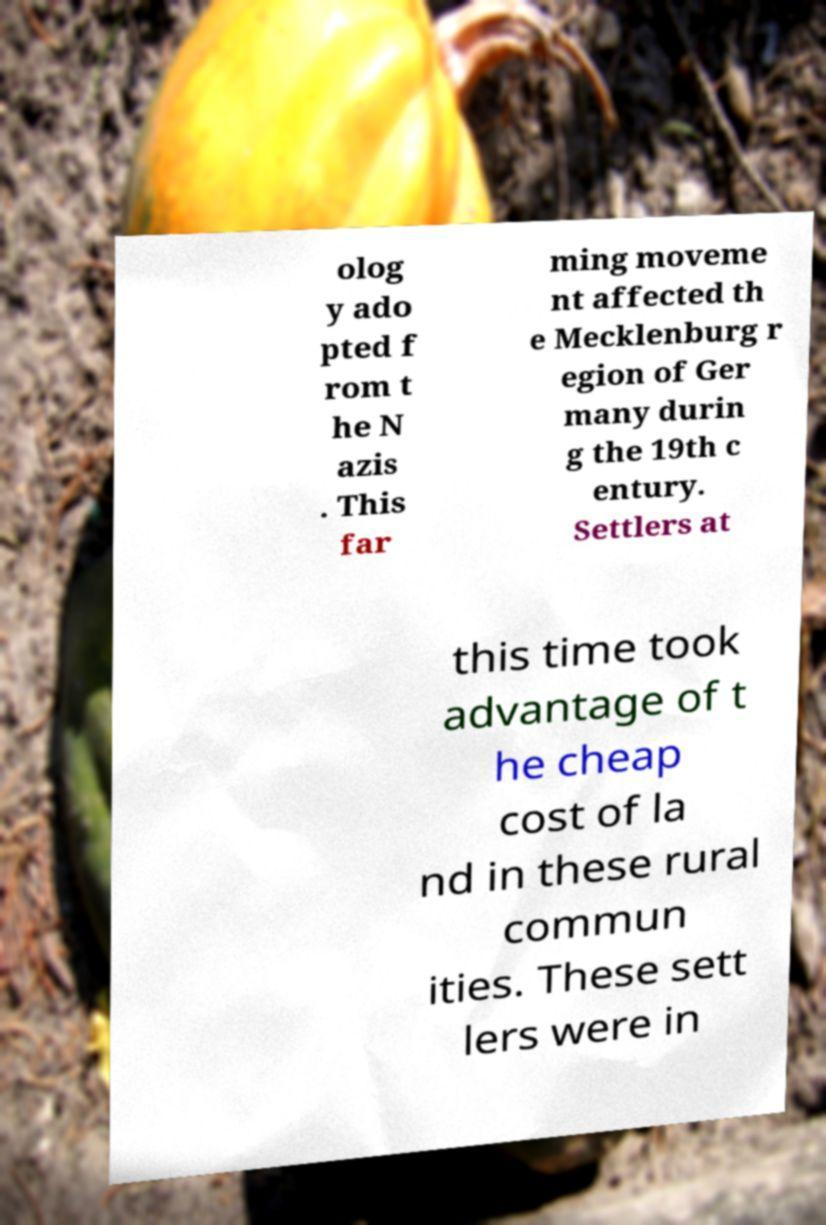What messages or text are displayed in this image? I need them in a readable, typed format. olog y ado pted f rom t he N azis . This far ming moveme nt affected th e Mecklenburg r egion of Ger many durin g the 19th c entury. Settlers at this time took advantage of t he cheap cost of la nd in these rural commun ities. These sett lers were in 